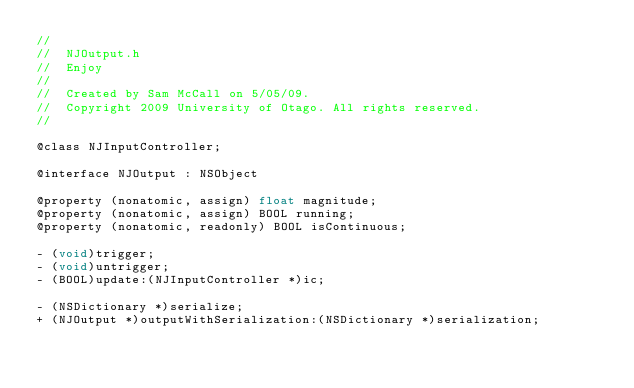<code> <loc_0><loc_0><loc_500><loc_500><_C_>//
//  NJOutput.h
//  Enjoy
//
//  Created by Sam McCall on 5/05/09.
//  Copyright 2009 University of Otago. All rights reserved.
//

@class NJInputController;

@interface NJOutput : NSObject

@property (nonatomic, assign) float magnitude;
@property (nonatomic, assign) BOOL running;
@property (nonatomic, readonly) BOOL isContinuous;

- (void)trigger;
- (void)untrigger;
- (BOOL)update:(NJInputController *)ic;

- (NSDictionary *)serialize;
+ (NJOutput *)outputWithSerialization:(NSDictionary *)serialization;</code> 